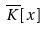<formula> <loc_0><loc_0><loc_500><loc_500>\overline { K } [ x ]</formula> 